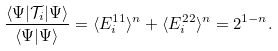Convert formula to latex. <formula><loc_0><loc_0><loc_500><loc_500>\frac { \langle \Psi | \mathcal { T } _ { i } | \Psi \rangle } { \langle \Psi | \Psi \rangle } = \langle E ^ { 1 1 } _ { i } \rangle ^ { n } + \langle E ^ { 2 2 } _ { i } \rangle ^ { n } = 2 ^ { 1 - n } .</formula> 